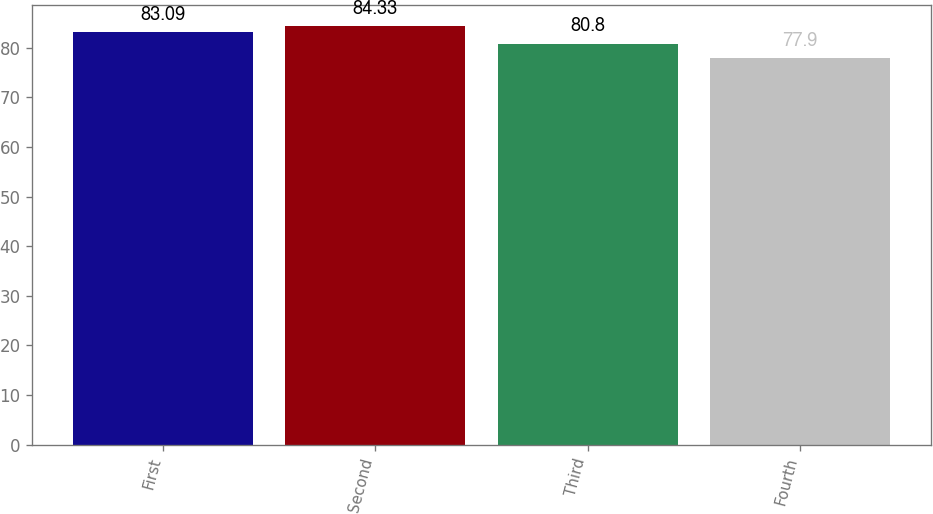<chart> <loc_0><loc_0><loc_500><loc_500><bar_chart><fcel>First<fcel>Second<fcel>Third<fcel>Fourth<nl><fcel>83.09<fcel>84.33<fcel>80.8<fcel>77.9<nl></chart> 